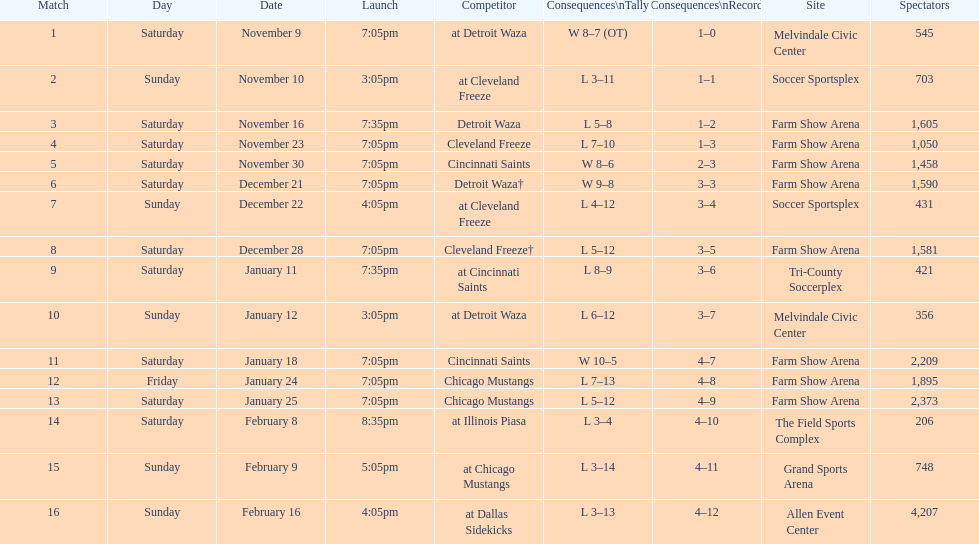Help me parse the entirety of this table. {'header': ['Match', 'Day', 'Date', 'Launch', 'Competitor', 'Consequences\\nTally', 'Consequences\\nRecord', 'Site', 'Spectators'], 'rows': [['1', 'Saturday', 'November 9', '7:05pm', 'at Detroit Waza', 'W 8–7 (OT)', '1–0', 'Melvindale Civic Center', '545'], ['2', 'Sunday', 'November 10', '3:05pm', 'at Cleveland Freeze', 'L 3–11', '1–1', 'Soccer Sportsplex', '703'], ['3', 'Saturday', 'November 16', '7:35pm', 'Detroit Waza', 'L 5–8', '1–2', 'Farm Show Arena', '1,605'], ['4', 'Saturday', 'November 23', '7:05pm', 'Cleveland Freeze', 'L 7–10', '1–3', 'Farm Show Arena', '1,050'], ['5', 'Saturday', 'November 30', '7:05pm', 'Cincinnati Saints', 'W 8–6', '2–3', 'Farm Show Arena', '1,458'], ['6', 'Saturday', 'December 21', '7:05pm', 'Detroit Waza†', 'W 9–8', '3–3', 'Farm Show Arena', '1,590'], ['7', 'Sunday', 'December 22', '4:05pm', 'at Cleveland Freeze', 'L 4–12', '3–4', 'Soccer Sportsplex', '431'], ['8', 'Saturday', 'December 28', '7:05pm', 'Cleveland Freeze†', 'L 5–12', '3–5', 'Farm Show Arena', '1,581'], ['9', 'Saturday', 'January 11', '7:35pm', 'at Cincinnati Saints', 'L 8–9', '3–6', 'Tri-County Soccerplex', '421'], ['10', 'Sunday', 'January 12', '3:05pm', 'at Detroit Waza', 'L 6–12', '3–7', 'Melvindale Civic Center', '356'], ['11', 'Saturday', 'January 18', '7:05pm', 'Cincinnati Saints', 'W 10–5', '4–7', 'Farm Show Arena', '2,209'], ['12', 'Friday', 'January 24', '7:05pm', 'Chicago Mustangs', 'L 7–13', '4–8', 'Farm Show Arena', '1,895'], ['13', 'Saturday', 'January 25', '7:05pm', 'Chicago Mustangs', 'L 5–12', '4–9', 'Farm Show Arena', '2,373'], ['14', 'Saturday', 'February 8', '8:35pm', 'at Illinois Piasa', 'L 3–4', '4–10', 'The Field Sports Complex', '206'], ['15', 'Sunday', 'February 9', '5:05pm', 'at Chicago Mustangs', 'L 3–14', '4–11', 'Grand Sports Arena', '748'], ['16', 'Sunday', 'February 16', '4:05pm', 'at Dallas Sidekicks', 'L 3–13', '4–12', 'Allen Event Center', '4,207']]} What is the date of the game after december 22? December 28. 